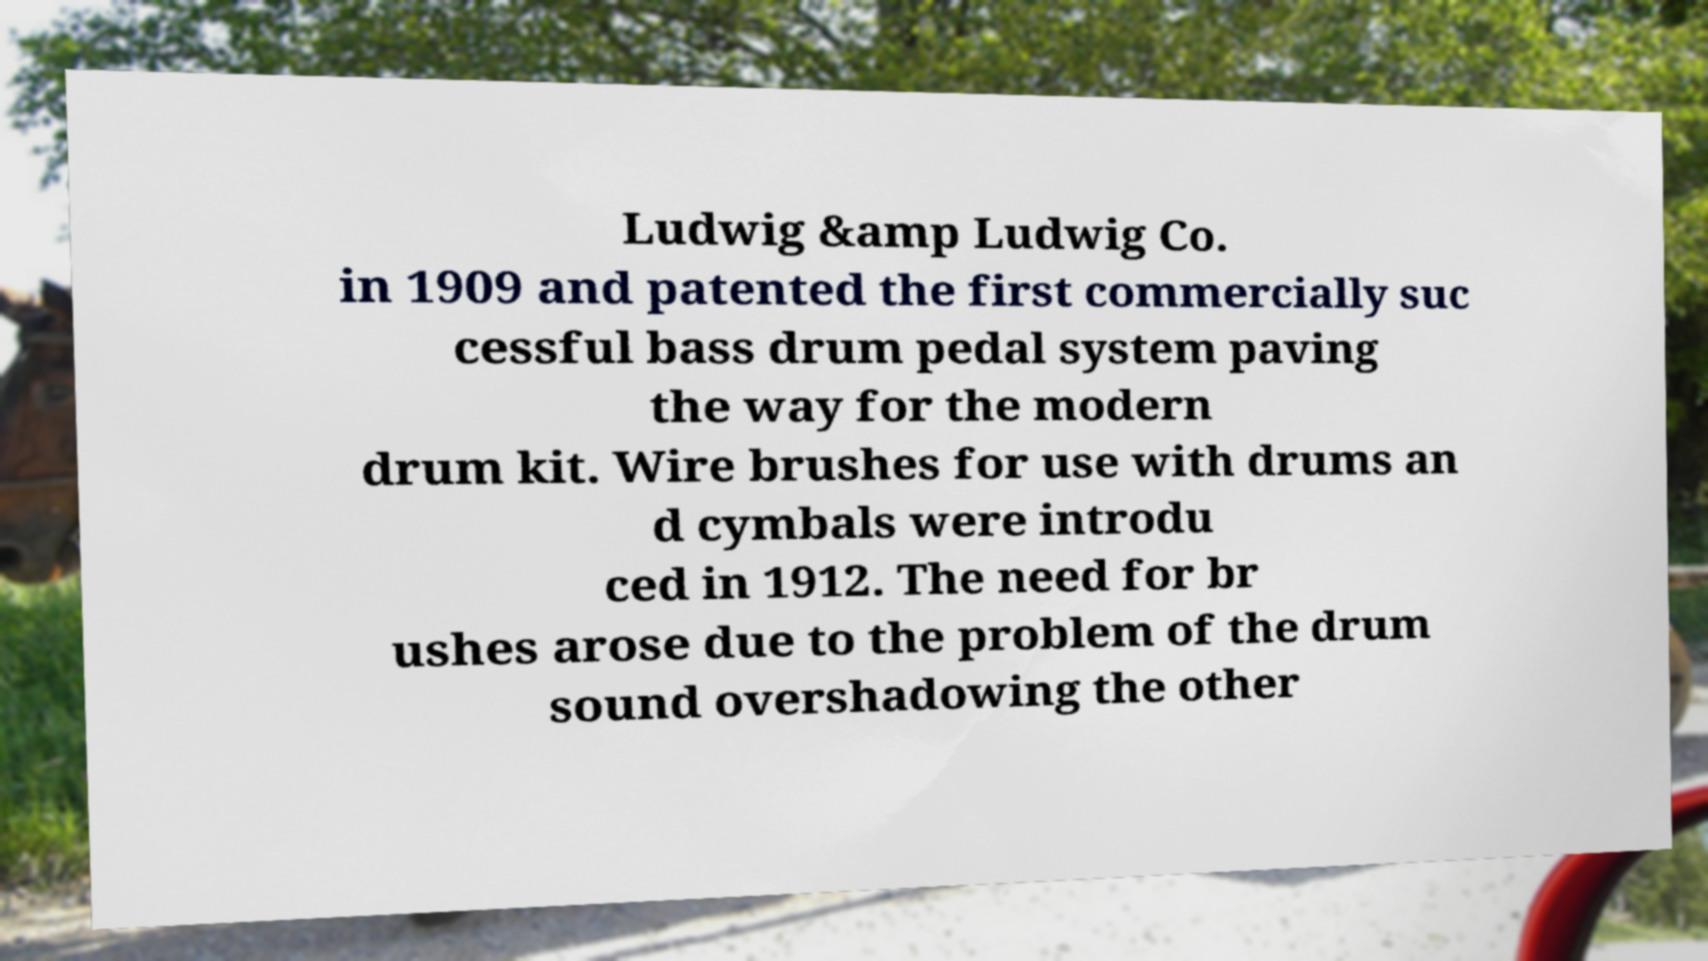Can you read and provide the text displayed in the image?This photo seems to have some interesting text. Can you extract and type it out for me? Ludwig &amp Ludwig Co. in 1909 and patented the first commercially suc cessful bass drum pedal system paving the way for the modern drum kit. Wire brushes for use with drums an d cymbals were introdu ced in 1912. The need for br ushes arose due to the problem of the drum sound overshadowing the other 